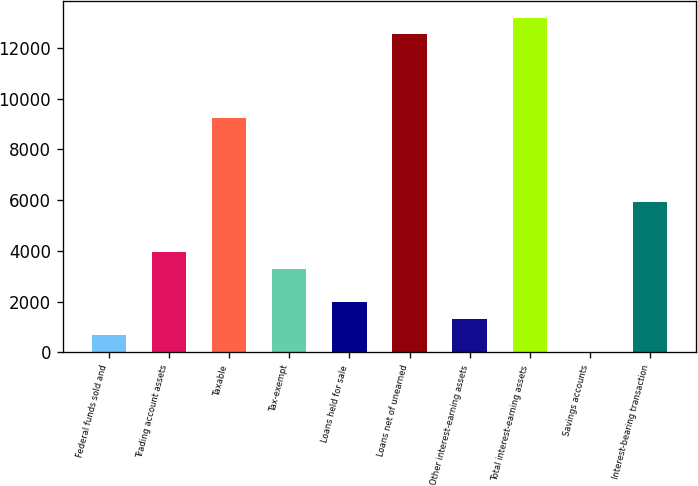Convert chart to OTSL. <chart><loc_0><loc_0><loc_500><loc_500><bar_chart><fcel>Federal funds sold and<fcel>Trading account assets<fcel>Taxable<fcel>Tax-exempt<fcel>Loans held for sale<fcel>Loans net of unearned<fcel>Other interest-earning assets<fcel>Total interest-earning assets<fcel>Savings accounts<fcel>Interest-bearing transaction<nl><fcel>663.6<fcel>3961.6<fcel>9238.4<fcel>3302<fcel>1982.8<fcel>12536.4<fcel>1323.2<fcel>13196<fcel>4<fcel>5940.4<nl></chart> 